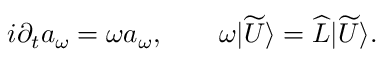<formula> <loc_0><loc_0><loc_500><loc_500>i \partial _ { t } a _ { \omega } = \omega a _ { \omega } , \quad \omega | \widetilde { U } \rangle = \widehat { L } | \widetilde { U } \rangle .</formula> 